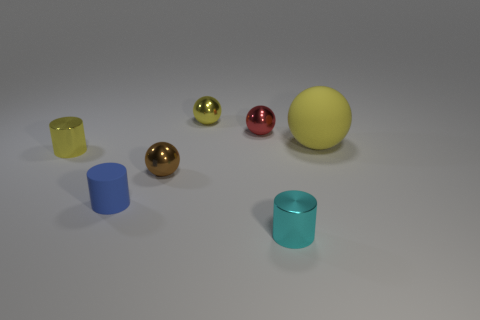Add 2 blue objects. How many objects exist? 9 Subtract all cylinders. How many objects are left? 4 Subtract all small shiny balls. Subtract all yellow things. How many objects are left? 1 Add 4 yellow matte balls. How many yellow matte balls are left? 5 Add 4 tiny yellow metallic things. How many tiny yellow metallic things exist? 6 Subtract 2 yellow balls. How many objects are left? 5 